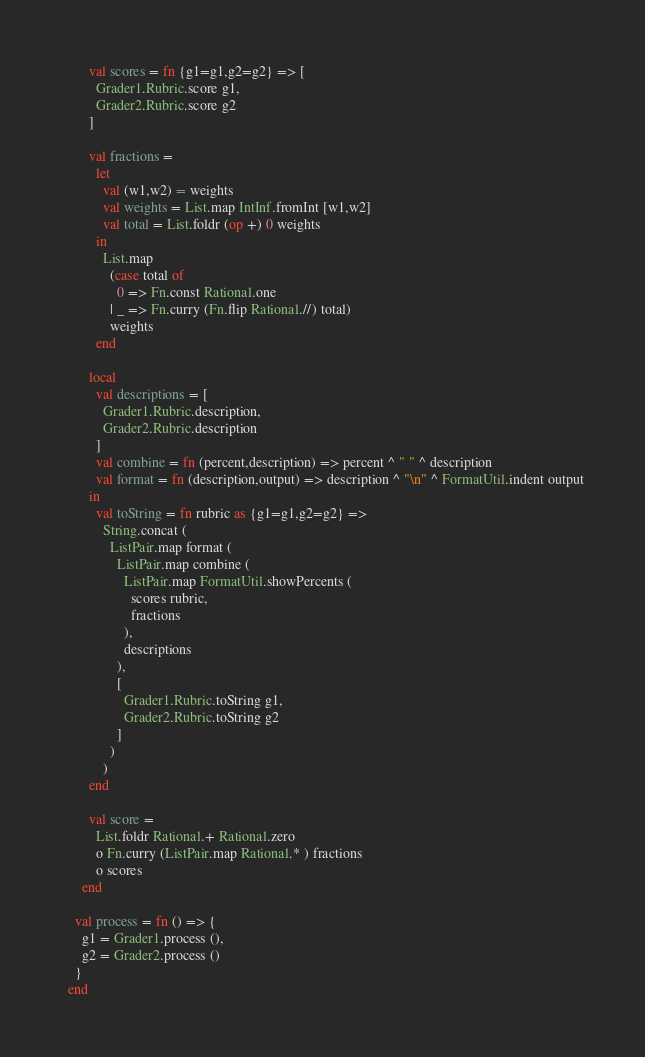Convert code to text. <code><loc_0><loc_0><loc_500><loc_500><_SML_>
        val scores = fn {g1=g1,g2=g2} => [
          Grader1.Rubric.score g1,
          Grader2.Rubric.score g2
        ]

        val fractions =
          let
            val (w1,w2) = weights
            val weights = List.map IntInf.fromInt [w1,w2]
            val total = List.foldr (op +) 0 weights
          in
            List.map
              (case total of
                0 => Fn.const Rational.one
              | _ => Fn.curry (Fn.flip Rational.//) total)
              weights
          end

        local
          val descriptions = [
            Grader1.Rubric.description,
            Grader2.Rubric.description
          ]
          val combine = fn (percent,description) => percent ^ " " ^ description
          val format = fn (description,output) => description ^ "\n" ^ FormatUtil.indent output
        in
          val toString = fn rubric as {g1=g1,g2=g2} =>
            String.concat (
              ListPair.map format (
                ListPair.map combine (
                  ListPair.map FormatUtil.showPercents (
                    scores rubric,
                    fractions
                  ),
                  descriptions
                ),
                [
                  Grader1.Rubric.toString g1,
                  Grader2.Rubric.toString g2
                ]
              )
            )
        end

        val score =
          List.foldr Rational.+ Rational.zero
          o Fn.curry (ListPair.map Rational.* ) fractions
          o scores
      end

    val process = fn () => {
      g1 = Grader1.process (),
      g2 = Grader2.process ()
    }
  end
</code> 